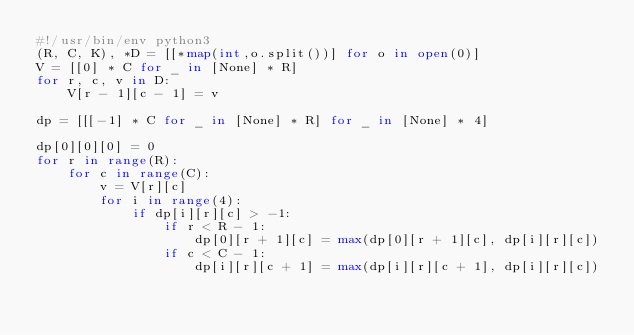Convert code to text. <code><loc_0><loc_0><loc_500><loc_500><_Python_>#!/usr/bin/env python3
(R, C, K), *D = [[*map(int,o.split())] for o in open(0)]
V = [[0] * C for _ in [None] * R]
for r, c, v in D:
    V[r - 1][c - 1] = v

dp = [[[-1] * C for _ in [None] * R] for _ in [None] * 4]

dp[0][0][0] = 0
for r in range(R):
    for c in range(C):
        v = V[r][c]
        for i in range(4):
            if dp[i][r][c] > -1:
                if r < R - 1:
                    dp[0][r + 1][c] = max(dp[0][r + 1][c], dp[i][r][c])
                if c < C - 1:
                    dp[i][r][c + 1] = max(dp[i][r][c + 1], dp[i][r][c])</code> 